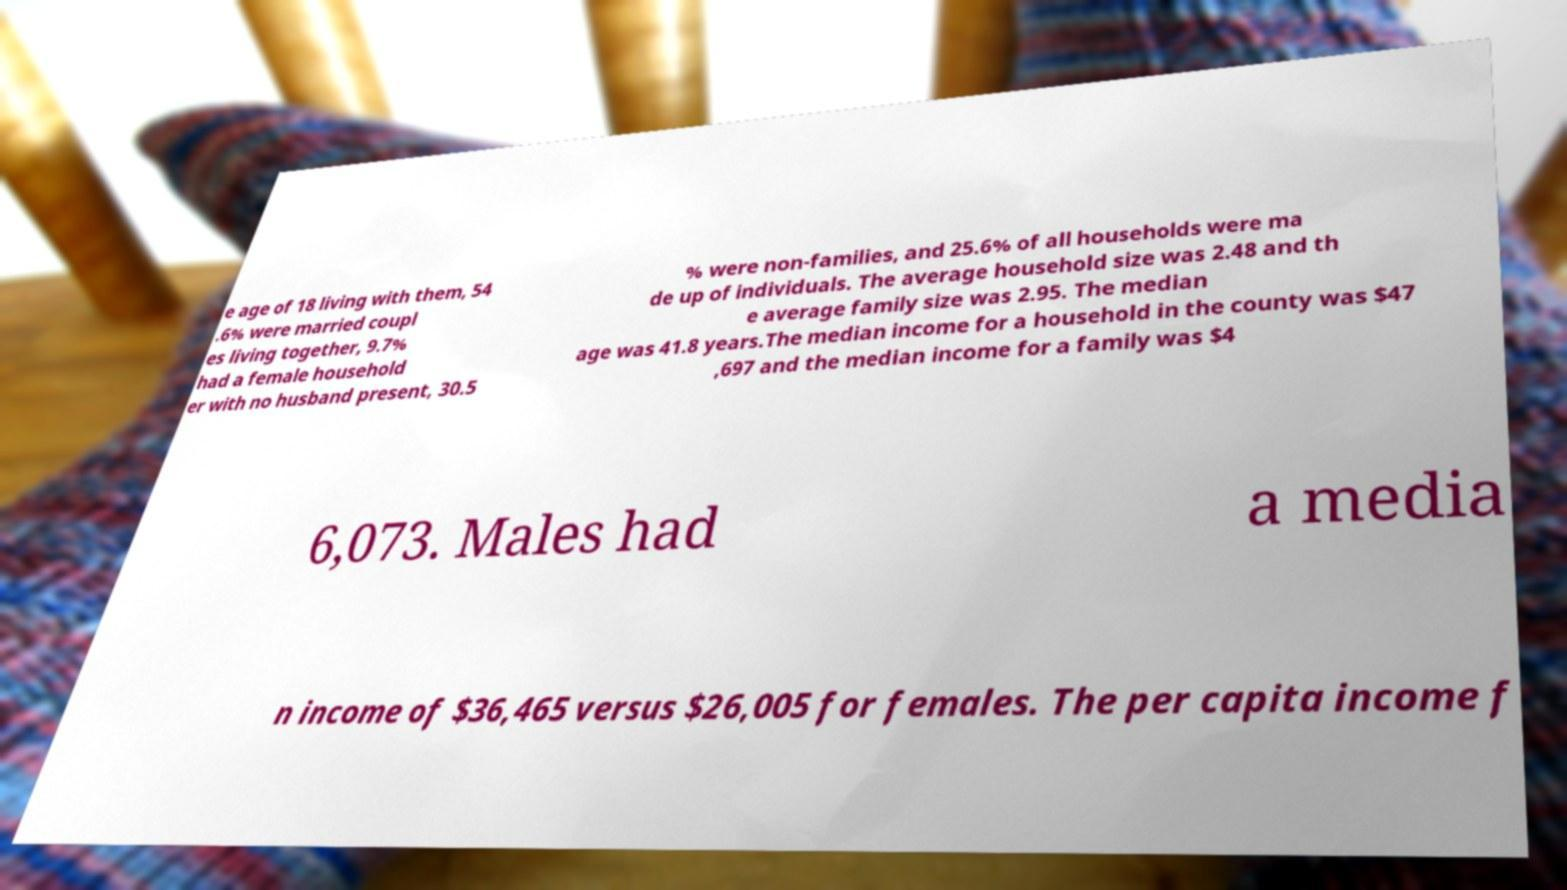Please read and relay the text visible in this image. What does it say? e age of 18 living with them, 54 .6% were married coupl es living together, 9.7% had a female household er with no husband present, 30.5 % were non-families, and 25.6% of all households were ma de up of individuals. The average household size was 2.48 and th e average family size was 2.95. The median age was 41.8 years.The median income for a household in the county was $47 ,697 and the median income for a family was $4 6,073. Males had a media n income of $36,465 versus $26,005 for females. The per capita income f 